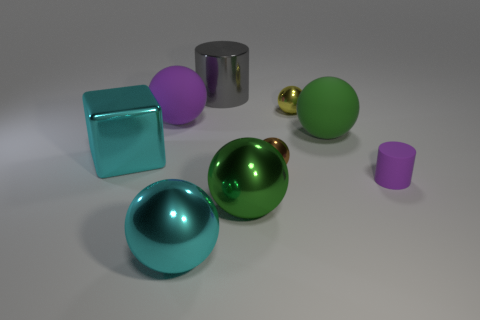Add 1 brown things. How many objects exist? 10 Subtract all big cyan balls. How many balls are left? 5 Subtract 1 blocks. How many blocks are left? 0 Subtract all brown cubes. Subtract all yellow cylinders. How many cubes are left? 1 Subtract all red spheres. How many purple cylinders are left? 1 Subtract all purple matte objects. Subtract all big gray cylinders. How many objects are left? 6 Add 1 tiny brown metal objects. How many tiny brown metal objects are left? 2 Add 6 yellow spheres. How many yellow spheres exist? 7 Subtract all cyan spheres. How many spheres are left? 5 Subtract 0 gray spheres. How many objects are left? 9 